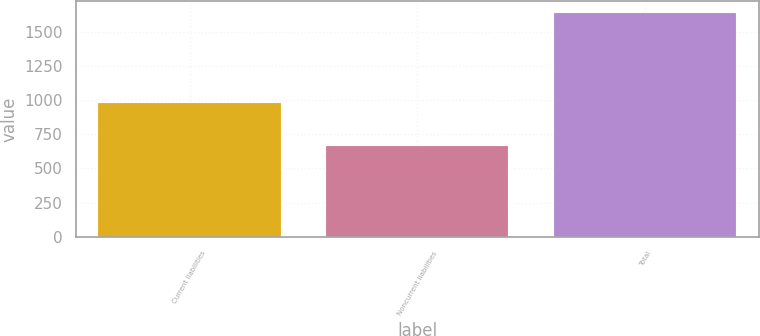Convert chart to OTSL. <chart><loc_0><loc_0><loc_500><loc_500><bar_chart><fcel>Current liabilities<fcel>Noncurrent liabilities<fcel>Total<nl><fcel>979<fcel>661<fcel>1640<nl></chart> 